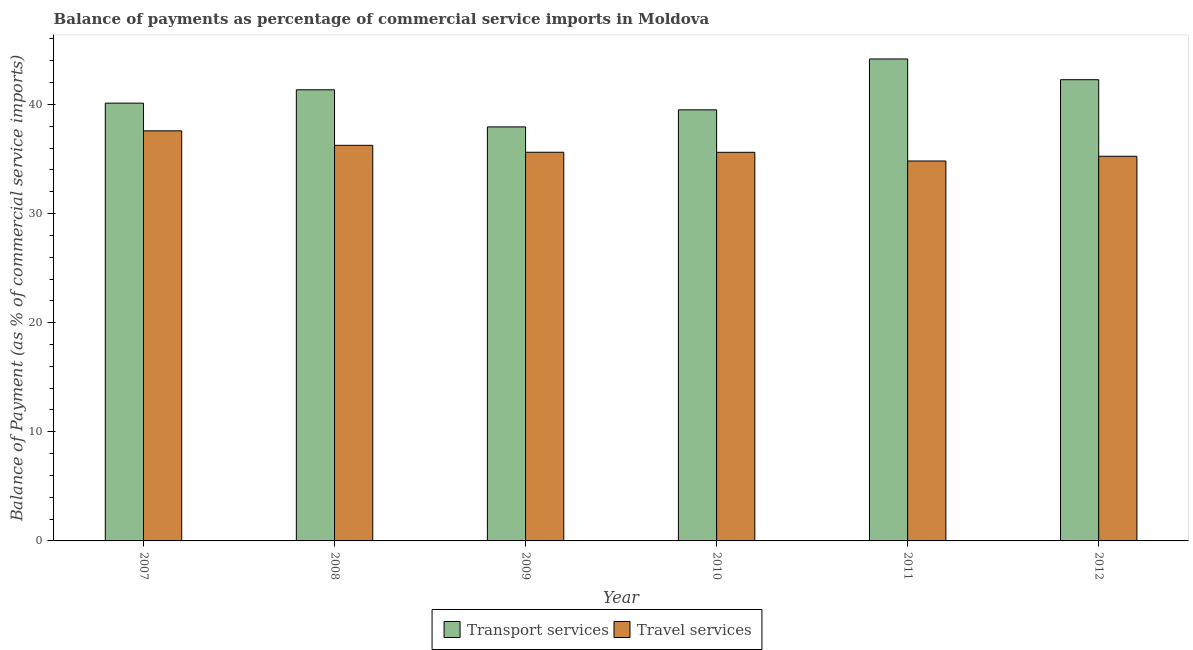How many groups of bars are there?
Your answer should be compact. 6. How many bars are there on the 5th tick from the left?
Make the answer very short. 2. In how many cases, is the number of bars for a given year not equal to the number of legend labels?
Make the answer very short. 0. What is the balance of payments of travel services in 2007?
Your response must be concise. 37.58. Across all years, what is the maximum balance of payments of transport services?
Make the answer very short. 44.17. Across all years, what is the minimum balance of payments of travel services?
Your answer should be compact. 34.82. In which year was the balance of payments of travel services maximum?
Your answer should be compact. 2007. What is the total balance of payments of travel services in the graph?
Ensure brevity in your answer.  215.14. What is the difference between the balance of payments of transport services in 2010 and that in 2011?
Provide a succinct answer. -4.66. What is the difference between the balance of payments of travel services in 2012 and the balance of payments of transport services in 2009?
Your answer should be compact. -0.37. What is the average balance of payments of transport services per year?
Keep it short and to the point. 40.89. In how many years, is the balance of payments of travel services greater than 44 %?
Give a very brief answer. 0. What is the ratio of the balance of payments of transport services in 2011 to that in 2012?
Provide a succinct answer. 1.04. What is the difference between the highest and the second highest balance of payments of transport services?
Your answer should be very brief. 1.9. What is the difference between the highest and the lowest balance of payments of transport services?
Your answer should be compact. 6.23. In how many years, is the balance of payments of transport services greater than the average balance of payments of transport services taken over all years?
Keep it short and to the point. 3. What does the 2nd bar from the left in 2009 represents?
Give a very brief answer. Travel services. What does the 1st bar from the right in 2009 represents?
Make the answer very short. Travel services. What is the difference between two consecutive major ticks on the Y-axis?
Your answer should be very brief. 10. Where does the legend appear in the graph?
Offer a terse response. Bottom center. What is the title of the graph?
Provide a succinct answer. Balance of payments as percentage of commercial service imports in Moldova. What is the label or title of the X-axis?
Your response must be concise. Year. What is the label or title of the Y-axis?
Offer a very short reply. Balance of Payment (as % of commercial service imports). What is the Balance of Payment (as % of commercial service imports) in Transport services in 2007?
Your answer should be compact. 40.12. What is the Balance of Payment (as % of commercial service imports) in Travel services in 2007?
Your answer should be very brief. 37.58. What is the Balance of Payment (as % of commercial service imports) of Transport services in 2008?
Your answer should be very brief. 41.34. What is the Balance of Payment (as % of commercial service imports) of Travel services in 2008?
Offer a terse response. 36.26. What is the Balance of Payment (as % of commercial service imports) in Transport services in 2009?
Your answer should be very brief. 37.94. What is the Balance of Payment (as % of commercial service imports) in Travel services in 2009?
Provide a short and direct response. 35.62. What is the Balance of Payment (as % of commercial service imports) in Transport services in 2010?
Offer a very short reply. 39.51. What is the Balance of Payment (as % of commercial service imports) of Travel services in 2010?
Offer a terse response. 35.61. What is the Balance of Payment (as % of commercial service imports) of Transport services in 2011?
Offer a terse response. 44.17. What is the Balance of Payment (as % of commercial service imports) in Travel services in 2011?
Give a very brief answer. 34.82. What is the Balance of Payment (as % of commercial service imports) in Transport services in 2012?
Provide a succinct answer. 42.27. What is the Balance of Payment (as % of commercial service imports) of Travel services in 2012?
Your answer should be compact. 35.25. Across all years, what is the maximum Balance of Payment (as % of commercial service imports) of Transport services?
Your response must be concise. 44.17. Across all years, what is the maximum Balance of Payment (as % of commercial service imports) of Travel services?
Provide a short and direct response. 37.58. Across all years, what is the minimum Balance of Payment (as % of commercial service imports) of Transport services?
Your answer should be very brief. 37.94. Across all years, what is the minimum Balance of Payment (as % of commercial service imports) in Travel services?
Keep it short and to the point. 34.82. What is the total Balance of Payment (as % of commercial service imports) in Transport services in the graph?
Make the answer very short. 245.35. What is the total Balance of Payment (as % of commercial service imports) of Travel services in the graph?
Provide a succinct answer. 215.14. What is the difference between the Balance of Payment (as % of commercial service imports) in Transport services in 2007 and that in 2008?
Your answer should be very brief. -1.22. What is the difference between the Balance of Payment (as % of commercial service imports) of Travel services in 2007 and that in 2008?
Your answer should be compact. 1.33. What is the difference between the Balance of Payment (as % of commercial service imports) of Transport services in 2007 and that in 2009?
Keep it short and to the point. 2.18. What is the difference between the Balance of Payment (as % of commercial service imports) in Travel services in 2007 and that in 2009?
Make the answer very short. 1.96. What is the difference between the Balance of Payment (as % of commercial service imports) of Transport services in 2007 and that in 2010?
Keep it short and to the point. 0.61. What is the difference between the Balance of Payment (as % of commercial service imports) of Travel services in 2007 and that in 2010?
Provide a short and direct response. 1.97. What is the difference between the Balance of Payment (as % of commercial service imports) of Transport services in 2007 and that in 2011?
Offer a terse response. -4.05. What is the difference between the Balance of Payment (as % of commercial service imports) of Travel services in 2007 and that in 2011?
Your answer should be very brief. 2.76. What is the difference between the Balance of Payment (as % of commercial service imports) of Transport services in 2007 and that in 2012?
Provide a short and direct response. -2.15. What is the difference between the Balance of Payment (as % of commercial service imports) of Travel services in 2007 and that in 2012?
Make the answer very short. 2.33. What is the difference between the Balance of Payment (as % of commercial service imports) in Transport services in 2008 and that in 2009?
Your answer should be very brief. 3.4. What is the difference between the Balance of Payment (as % of commercial service imports) in Travel services in 2008 and that in 2009?
Offer a terse response. 0.64. What is the difference between the Balance of Payment (as % of commercial service imports) of Transport services in 2008 and that in 2010?
Provide a short and direct response. 1.84. What is the difference between the Balance of Payment (as % of commercial service imports) of Travel services in 2008 and that in 2010?
Offer a terse response. 0.64. What is the difference between the Balance of Payment (as % of commercial service imports) of Transport services in 2008 and that in 2011?
Offer a very short reply. -2.82. What is the difference between the Balance of Payment (as % of commercial service imports) of Travel services in 2008 and that in 2011?
Ensure brevity in your answer.  1.44. What is the difference between the Balance of Payment (as % of commercial service imports) of Transport services in 2008 and that in 2012?
Provide a short and direct response. -0.92. What is the difference between the Balance of Payment (as % of commercial service imports) in Transport services in 2009 and that in 2010?
Provide a succinct answer. -1.56. What is the difference between the Balance of Payment (as % of commercial service imports) of Travel services in 2009 and that in 2010?
Give a very brief answer. 0. What is the difference between the Balance of Payment (as % of commercial service imports) of Transport services in 2009 and that in 2011?
Your response must be concise. -6.23. What is the difference between the Balance of Payment (as % of commercial service imports) in Travel services in 2009 and that in 2011?
Offer a terse response. 0.8. What is the difference between the Balance of Payment (as % of commercial service imports) in Transport services in 2009 and that in 2012?
Your answer should be compact. -4.33. What is the difference between the Balance of Payment (as % of commercial service imports) of Travel services in 2009 and that in 2012?
Make the answer very short. 0.37. What is the difference between the Balance of Payment (as % of commercial service imports) of Transport services in 2010 and that in 2011?
Make the answer very short. -4.66. What is the difference between the Balance of Payment (as % of commercial service imports) in Travel services in 2010 and that in 2011?
Provide a succinct answer. 0.8. What is the difference between the Balance of Payment (as % of commercial service imports) of Transport services in 2010 and that in 2012?
Offer a very short reply. -2.76. What is the difference between the Balance of Payment (as % of commercial service imports) of Travel services in 2010 and that in 2012?
Make the answer very short. 0.36. What is the difference between the Balance of Payment (as % of commercial service imports) of Transport services in 2011 and that in 2012?
Ensure brevity in your answer.  1.9. What is the difference between the Balance of Payment (as % of commercial service imports) of Travel services in 2011 and that in 2012?
Ensure brevity in your answer.  -0.43. What is the difference between the Balance of Payment (as % of commercial service imports) in Transport services in 2007 and the Balance of Payment (as % of commercial service imports) in Travel services in 2008?
Give a very brief answer. 3.86. What is the difference between the Balance of Payment (as % of commercial service imports) of Transport services in 2007 and the Balance of Payment (as % of commercial service imports) of Travel services in 2009?
Keep it short and to the point. 4.5. What is the difference between the Balance of Payment (as % of commercial service imports) in Transport services in 2007 and the Balance of Payment (as % of commercial service imports) in Travel services in 2010?
Make the answer very short. 4.51. What is the difference between the Balance of Payment (as % of commercial service imports) of Transport services in 2007 and the Balance of Payment (as % of commercial service imports) of Travel services in 2011?
Offer a very short reply. 5.3. What is the difference between the Balance of Payment (as % of commercial service imports) of Transport services in 2007 and the Balance of Payment (as % of commercial service imports) of Travel services in 2012?
Give a very brief answer. 4.87. What is the difference between the Balance of Payment (as % of commercial service imports) of Transport services in 2008 and the Balance of Payment (as % of commercial service imports) of Travel services in 2009?
Offer a terse response. 5.73. What is the difference between the Balance of Payment (as % of commercial service imports) of Transport services in 2008 and the Balance of Payment (as % of commercial service imports) of Travel services in 2010?
Keep it short and to the point. 5.73. What is the difference between the Balance of Payment (as % of commercial service imports) of Transport services in 2008 and the Balance of Payment (as % of commercial service imports) of Travel services in 2011?
Your answer should be compact. 6.53. What is the difference between the Balance of Payment (as % of commercial service imports) in Transport services in 2008 and the Balance of Payment (as % of commercial service imports) in Travel services in 2012?
Keep it short and to the point. 6.09. What is the difference between the Balance of Payment (as % of commercial service imports) of Transport services in 2009 and the Balance of Payment (as % of commercial service imports) of Travel services in 2010?
Provide a short and direct response. 2.33. What is the difference between the Balance of Payment (as % of commercial service imports) of Transport services in 2009 and the Balance of Payment (as % of commercial service imports) of Travel services in 2011?
Your response must be concise. 3.12. What is the difference between the Balance of Payment (as % of commercial service imports) in Transport services in 2009 and the Balance of Payment (as % of commercial service imports) in Travel services in 2012?
Give a very brief answer. 2.69. What is the difference between the Balance of Payment (as % of commercial service imports) in Transport services in 2010 and the Balance of Payment (as % of commercial service imports) in Travel services in 2011?
Your answer should be compact. 4.69. What is the difference between the Balance of Payment (as % of commercial service imports) of Transport services in 2010 and the Balance of Payment (as % of commercial service imports) of Travel services in 2012?
Give a very brief answer. 4.26. What is the difference between the Balance of Payment (as % of commercial service imports) of Transport services in 2011 and the Balance of Payment (as % of commercial service imports) of Travel services in 2012?
Provide a short and direct response. 8.92. What is the average Balance of Payment (as % of commercial service imports) of Transport services per year?
Your response must be concise. 40.89. What is the average Balance of Payment (as % of commercial service imports) in Travel services per year?
Make the answer very short. 35.86. In the year 2007, what is the difference between the Balance of Payment (as % of commercial service imports) in Transport services and Balance of Payment (as % of commercial service imports) in Travel services?
Offer a terse response. 2.54. In the year 2008, what is the difference between the Balance of Payment (as % of commercial service imports) in Transport services and Balance of Payment (as % of commercial service imports) in Travel services?
Offer a terse response. 5.09. In the year 2009, what is the difference between the Balance of Payment (as % of commercial service imports) of Transport services and Balance of Payment (as % of commercial service imports) of Travel services?
Ensure brevity in your answer.  2.32. In the year 2010, what is the difference between the Balance of Payment (as % of commercial service imports) in Transport services and Balance of Payment (as % of commercial service imports) in Travel services?
Your answer should be very brief. 3.89. In the year 2011, what is the difference between the Balance of Payment (as % of commercial service imports) in Transport services and Balance of Payment (as % of commercial service imports) in Travel services?
Make the answer very short. 9.35. In the year 2012, what is the difference between the Balance of Payment (as % of commercial service imports) of Transport services and Balance of Payment (as % of commercial service imports) of Travel services?
Offer a very short reply. 7.02. What is the ratio of the Balance of Payment (as % of commercial service imports) of Transport services in 2007 to that in 2008?
Your response must be concise. 0.97. What is the ratio of the Balance of Payment (as % of commercial service imports) in Travel services in 2007 to that in 2008?
Your response must be concise. 1.04. What is the ratio of the Balance of Payment (as % of commercial service imports) of Transport services in 2007 to that in 2009?
Your response must be concise. 1.06. What is the ratio of the Balance of Payment (as % of commercial service imports) of Travel services in 2007 to that in 2009?
Your answer should be compact. 1.06. What is the ratio of the Balance of Payment (as % of commercial service imports) of Transport services in 2007 to that in 2010?
Your response must be concise. 1.02. What is the ratio of the Balance of Payment (as % of commercial service imports) in Travel services in 2007 to that in 2010?
Your answer should be very brief. 1.06. What is the ratio of the Balance of Payment (as % of commercial service imports) of Transport services in 2007 to that in 2011?
Ensure brevity in your answer.  0.91. What is the ratio of the Balance of Payment (as % of commercial service imports) in Travel services in 2007 to that in 2011?
Offer a terse response. 1.08. What is the ratio of the Balance of Payment (as % of commercial service imports) in Transport services in 2007 to that in 2012?
Give a very brief answer. 0.95. What is the ratio of the Balance of Payment (as % of commercial service imports) of Travel services in 2007 to that in 2012?
Provide a short and direct response. 1.07. What is the ratio of the Balance of Payment (as % of commercial service imports) of Transport services in 2008 to that in 2009?
Keep it short and to the point. 1.09. What is the ratio of the Balance of Payment (as % of commercial service imports) in Travel services in 2008 to that in 2009?
Your response must be concise. 1.02. What is the ratio of the Balance of Payment (as % of commercial service imports) of Transport services in 2008 to that in 2010?
Keep it short and to the point. 1.05. What is the ratio of the Balance of Payment (as % of commercial service imports) in Travel services in 2008 to that in 2010?
Ensure brevity in your answer.  1.02. What is the ratio of the Balance of Payment (as % of commercial service imports) in Transport services in 2008 to that in 2011?
Offer a terse response. 0.94. What is the ratio of the Balance of Payment (as % of commercial service imports) in Travel services in 2008 to that in 2011?
Ensure brevity in your answer.  1.04. What is the ratio of the Balance of Payment (as % of commercial service imports) of Transport services in 2008 to that in 2012?
Provide a short and direct response. 0.98. What is the ratio of the Balance of Payment (as % of commercial service imports) of Travel services in 2008 to that in 2012?
Offer a very short reply. 1.03. What is the ratio of the Balance of Payment (as % of commercial service imports) in Transport services in 2009 to that in 2010?
Provide a short and direct response. 0.96. What is the ratio of the Balance of Payment (as % of commercial service imports) of Transport services in 2009 to that in 2011?
Ensure brevity in your answer.  0.86. What is the ratio of the Balance of Payment (as % of commercial service imports) of Transport services in 2009 to that in 2012?
Offer a very short reply. 0.9. What is the ratio of the Balance of Payment (as % of commercial service imports) in Travel services in 2009 to that in 2012?
Your response must be concise. 1.01. What is the ratio of the Balance of Payment (as % of commercial service imports) of Transport services in 2010 to that in 2011?
Your response must be concise. 0.89. What is the ratio of the Balance of Payment (as % of commercial service imports) in Travel services in 2010 to that in 2011?
Offer a very short reply. 1.02. What is the ratio of the Balance of Payment (as % of commercial service imports) of Transport services in 2010 to that in 2012?
Make the answer very short. 0.93. What is the ratio of the Balance of Payment (as % of commercial service imports) in Travel services in 2010 to that in 2012?
Ensure brevity in your answer.  1.01. What is the ratio of the Balance of Payment (as % of commercial service imports) in Transport services in 2011 to that in 2012?
Keep it short and to the point. 1.04. What is the ratio of the Balance of Payment (as % of commercial service imports) in Travel services in 2011 to that in 2012?
Your answer should be very brief. 0.99. What is the difference between the highest and the second highest Balance of Payment (as % of commercial service imports) in Transport services?
Your answer should be compact. 1.9. What is the difference between the highest and the second highest Balance of Payment (as % of commercial service imports) in Travel services?
Provide a succinct answer. 1.33. What is the difference between the highest and the lowest Balance of Payment (as % of commercial service imports) of Transport services?
Make the answer very short. 6.23. What is the difference between the highest and the lowest Balance of Payment (as % of commercial service imports) of Travel services?
Keep it short and to the point. 2.76. 